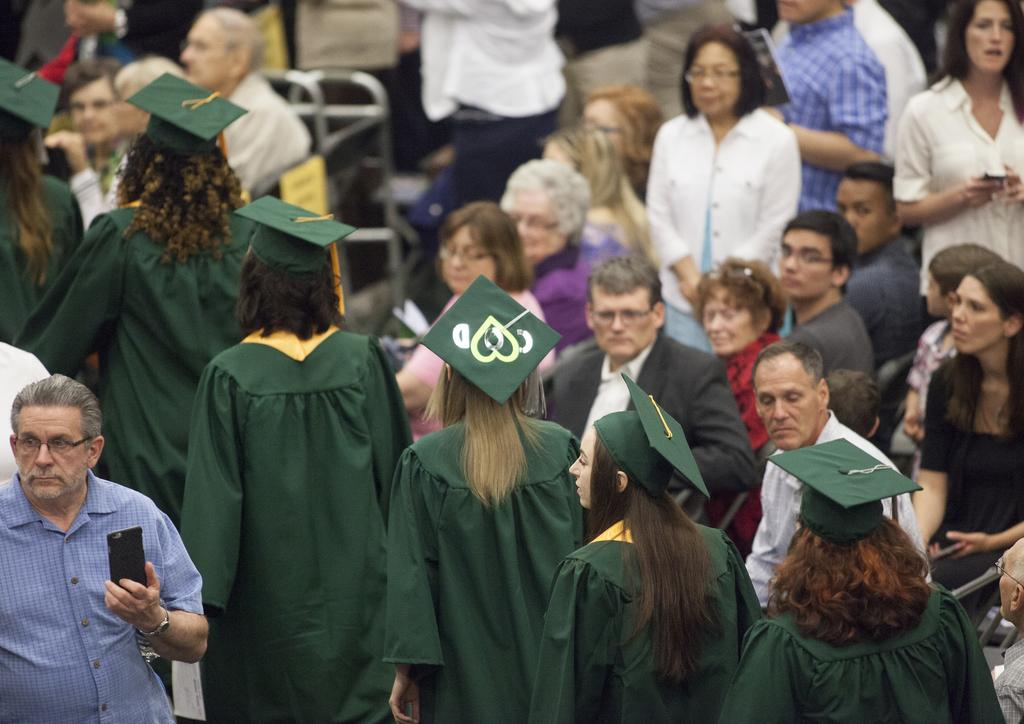How many people are in the image? There are people in the image, but the exact number is not specified. What are the people doing in the image? Some people are standing, while others are sitting, and they are watching something. What are the people holding in their hands? The people are holding something in their hands, but the specific object is not mentioned. What is the annual income of the people in the image? There is no information about the people's income in the image, so it cannot be determined. 